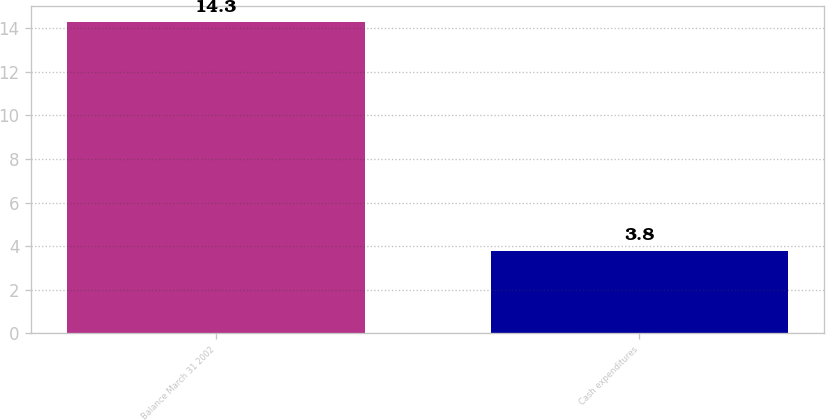<chart> <loc_0><loc_0><loc_500><loc_500><bar_chart><fcel>Balance March 31 2002<fcel>Cash expenditures<nl><fcel>14.3<fcel>3.8<nl></chart> 